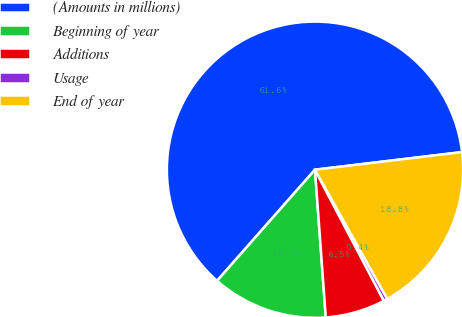Convert chart to OTSL. <chart><loc_0><loc_0><loc_500><loc_500><pie_chart><fcel>(Amounts in millions)<fcel>Beginning of year<fcel>Additions<fcel>Usage<fcel>End of year<nl><fcel>61.61%<fcel>12.66%<fcel>6.54%<fcel>0.42%<fcel>18.78%<nl></chart> 